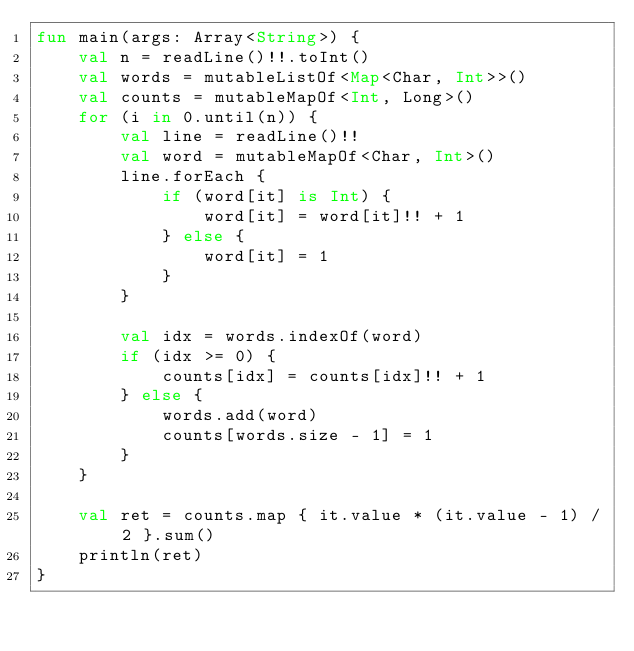Convert code to text. <code><loc_0><loc_0><loc_500><loc_500><_Kotlin_>fun main(args: Array<String>) {
    val n = readLine()!!.toInt()
    val words = mutableListOf<Map<Char, Int>>()
    val counts = mutableMapOf<Int, Long>()
    for (i in 0.until(n)) {
        val line = readLine()!!
        val word = mutableMapOf<Char, Int>()
        line.forEach {
            if (word[it] is Int) {
                word[it] = word[it]!! + 1
            } else {
                word[it] = 1
            }
        }

        val idx = words.indexOf(word)
        if (idx >= 0) {
            counts[idx] = counts[idx]!! + 1
        } else {
            words.add(word)
            counts[words.size - 1] = 1
        }
    }

    val ret = counts.map { it.value * (it.value - 1) / 2 }.sum()
    println(ret)
}</code> 